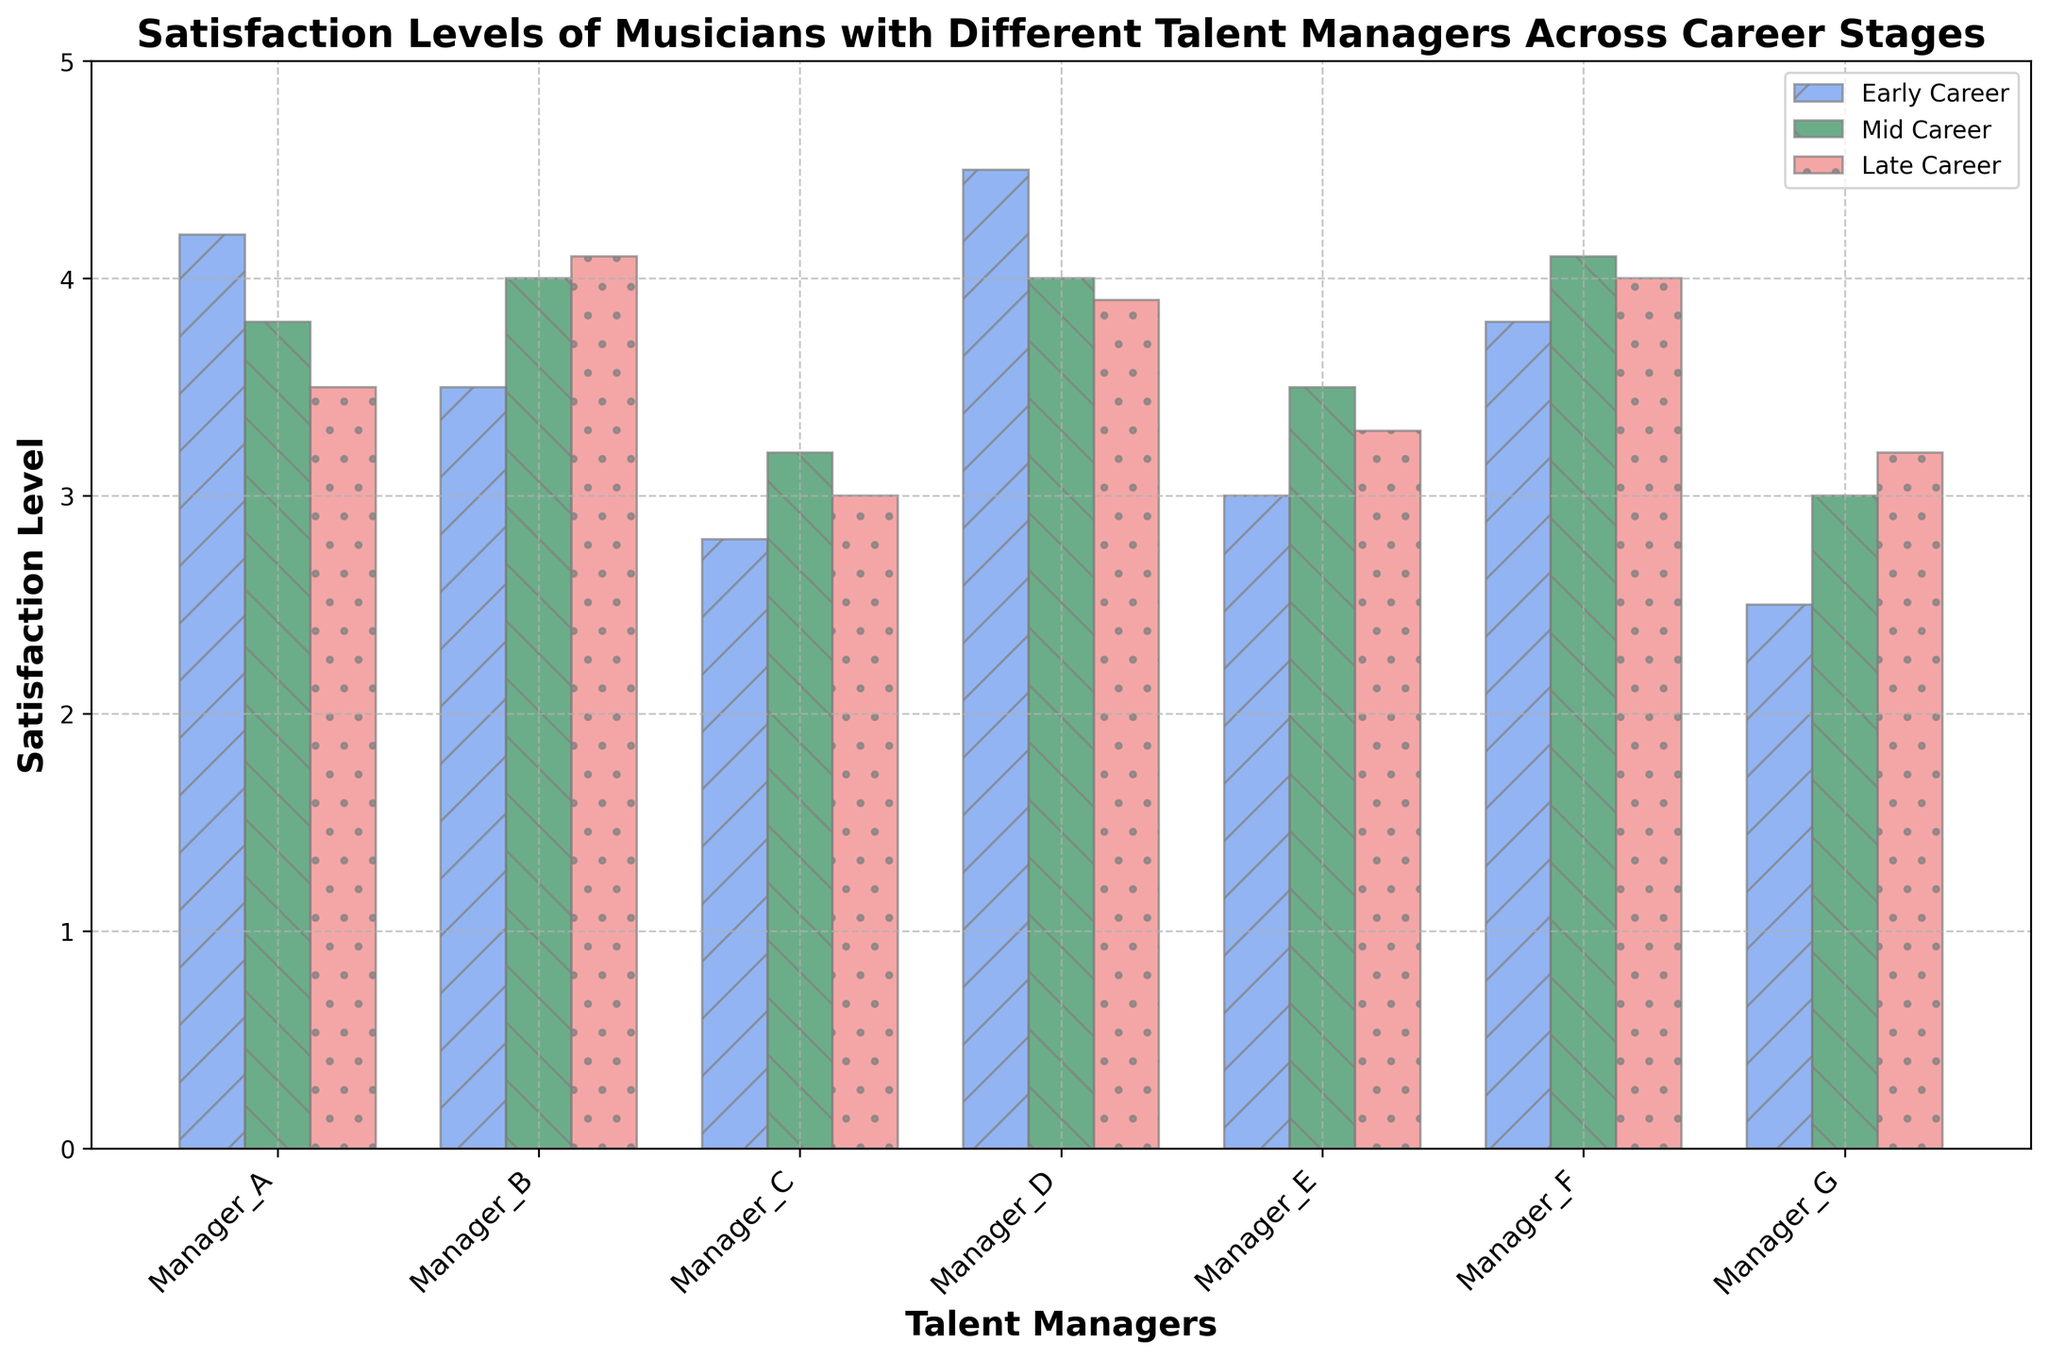How does the satisfaction of Manager D compare across the career stages? Manager D has satisfaction levels of 4.5 in Early Career, 4.0 in Mid Career, and 3.9 in Late Career. Comparing these values, the satisfaction level decreases as the career stage progresses.
Answer: The satisfaction decreases from 4.5 (Early) to 4.0 (Mid) to 3.9 (Late) What is the average satisfaction level for musicians in the Early Career stage for all managers? The satisfaction levels in the Early Career stage are 4.2, 3.5, 2.8, 4.5, 3.0, 3.8, and 2.5. To compute the average, sum these values: 4.2 + 3.5 + 2.8 + 4.5 + 3.0 + 3.8 + 2.5 = 24.3. Then, divide by the number of managers, which is 7: \( \frac{24.3}{7} \approx 3.47 \).
Answer: Approximately 3.47 Which manager has the highest satisfaction level in the Mid Career stage? The satisfaction levels in the Mid Career stage are 3.8, 4.0, 3.2, 4.0, 3.5, 4.1, and 3.0. The highest value is 4.1, which belongs to Manager F.
Answer: Manager F How does Manager B's satisfaction change from Early Career to Late Career? Manager B has a satisfaction level of 3.5 in Early Career, 4.0 in Mid Career, and 4.1 in Late Career. The satisfaction increases from Early to Mid (3.5 to 4.0) and then slightly increases from Mid to Late (4.0 to 4.1).
Answer: Increases from 3.5 to 4.1 Which career stage shows the least variation in satisfaction levels among different managers? To identify the least variation, observe the spread in satisfaction levels for each career stage. Early Career ranges from 2.5 to 4.5 (spread of 2.0), Mid Career ranges from 3.0 to 4.1 (spread of 1.1), and Late Career ranges from 3.0 to 4.1 (spread of 1.1). Both Mid Career and Late Career have the smallest spread of 1.1.
Answer: Mid Career and Late Career What is the combined satisfaction score of Manager E across all career stages? Manager E has satisfaction levels of 3.0 in Early Career, 3.5 in Mid Career, and 3.3 in Late Career. To find the combined score, sum these values: 3.0 + 3.5 + 3.3 = 9.8.
Answer: 9.8 Identify the manager who has the lowest satisfaction in both the Early Career and Late Career stages. In the Early Career stage, Manager G has the lowest satisfaction (2.5). In the Late Career stage, Manager C has the lowest satisfaction (3.0). No single manager has the lowest satisfaction in both stages.
Answer: No single manager What trend is observed in Manager A's satisfaction levels across different career stages? Manager A has satisfaction levels of 4.2 in Early Career, 3.8 in Mid Career, and 3.5 in Late Career. The trend shows a decreasing satisfaction level from Early to Mid, and from Mid to Late.
Answer: Decreasing Compare Manager D's satisfaction level in the Mid Career stage with Manager F's satisfaction level in the same stage. In the Mid Career stage, Manager D has a satisfaction level of 4.0, and Manager F has a satisfaction level of 4.1. Comparing these values, Manager F's satisfaction level is slightly higher than Manager D's.
Answer: Manager F is higher 